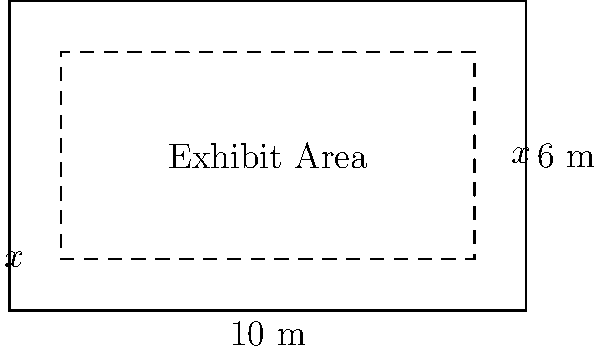A historical museum is planning a new exhibit in a rectangular room measuring 10 meters by 6 meters. The curator wants to create a walkway around the exhibit area, with the walkway having a consistent width $x$ on all sides. If the goal is to maximize the area of the exhibit space, what should be the width of the walkway? Express your answer in terms of meters. Let's approach this step-by-step:

1) The total area of the room is $10 \times 6 = 60$ square meters.

2) The exhibit area will be a rectangle with dimensions $(10-2x)$ by $(6-2x)$, where $x$ is the width of the walkway.

3) The area of the exhibit space, $A$, as a function of $x$ is:
   $A(x) = (10-2x)(6-2x)$

4) Expanding this:
   $A(x) = 60 - 20x - 12x + 4x^2 = 4x^2 - 32x + 60$

5) To find the maximum value of $A(x)$, we need to find where its derivative equals zero:
   $A'(x) = 8x - 32$

6) Set this equal to zero and solve:
   $8x - 32 = 0$
   $8x = 32$
   $x = 4$

7) To confirm this is a maximum, we can check the second derivative:
   $A''(x) = 8$, which is positive, confirming a minimum.

8) However, $x = 4$ doesn't make sense in our context, as it would make the exhibit area zero.

9) The other critical point to check is at the edge of our domain. The walkway width can't be negative or greater than 3 (half the shorter side of the room).

10) Evaluating $A(x)$ at $x = 0$ and $x = 3$:
    $A(0) = 60$
    $A(3) = 4(9) - 32(3) + 60 = 36 - 96 + 60 = 0$

11) Therefore, the maximum exhibit area occurs when the walkway width is as small as possible, which in practical terms would be the minimum width needed for people to walk comfortably.
Answer: Minimum practical width (approaching 0 m) 